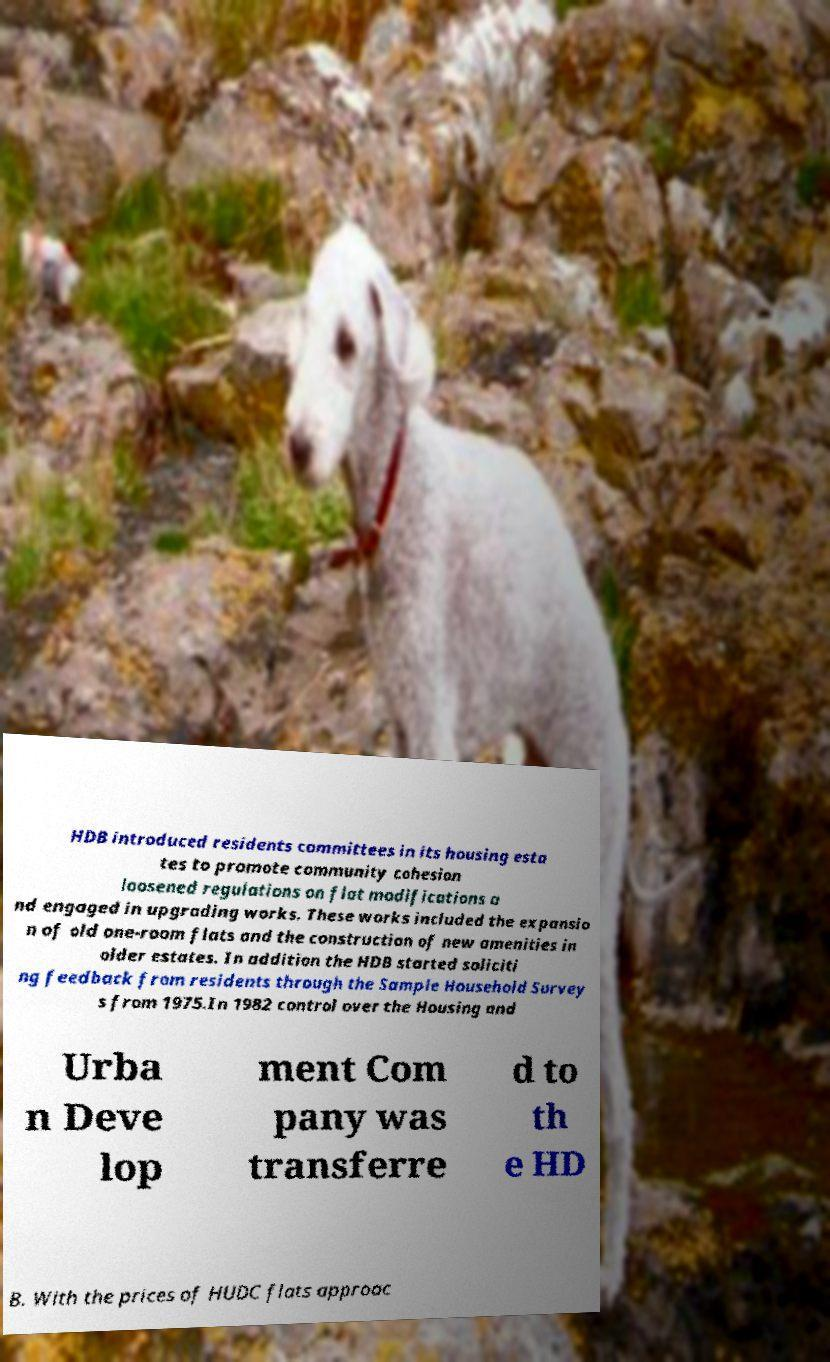There's text embedded in this image that I need extracted. Can you transcribe it verbatim? HDB introduced residents committees in its housing esta tes to promote community cohesion loosened regulations on flat modifications a nd engaged in upgrading works. These works included the expansio n of old one-room flats and the construction of new amenities in older estates. In addition the HDB started soliciti ng feedback from residents through the Sample Household Survey s from 1975.In 1982 control over the Housing and Urba n Deve lop ment Com pany was transferre d to th e HD B. With the prices of HUDC flats approac 